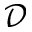Convert formula to latex. <formula><loc_0><loc_0><loc_500><loc_500>\mathcal { D }</formula> 